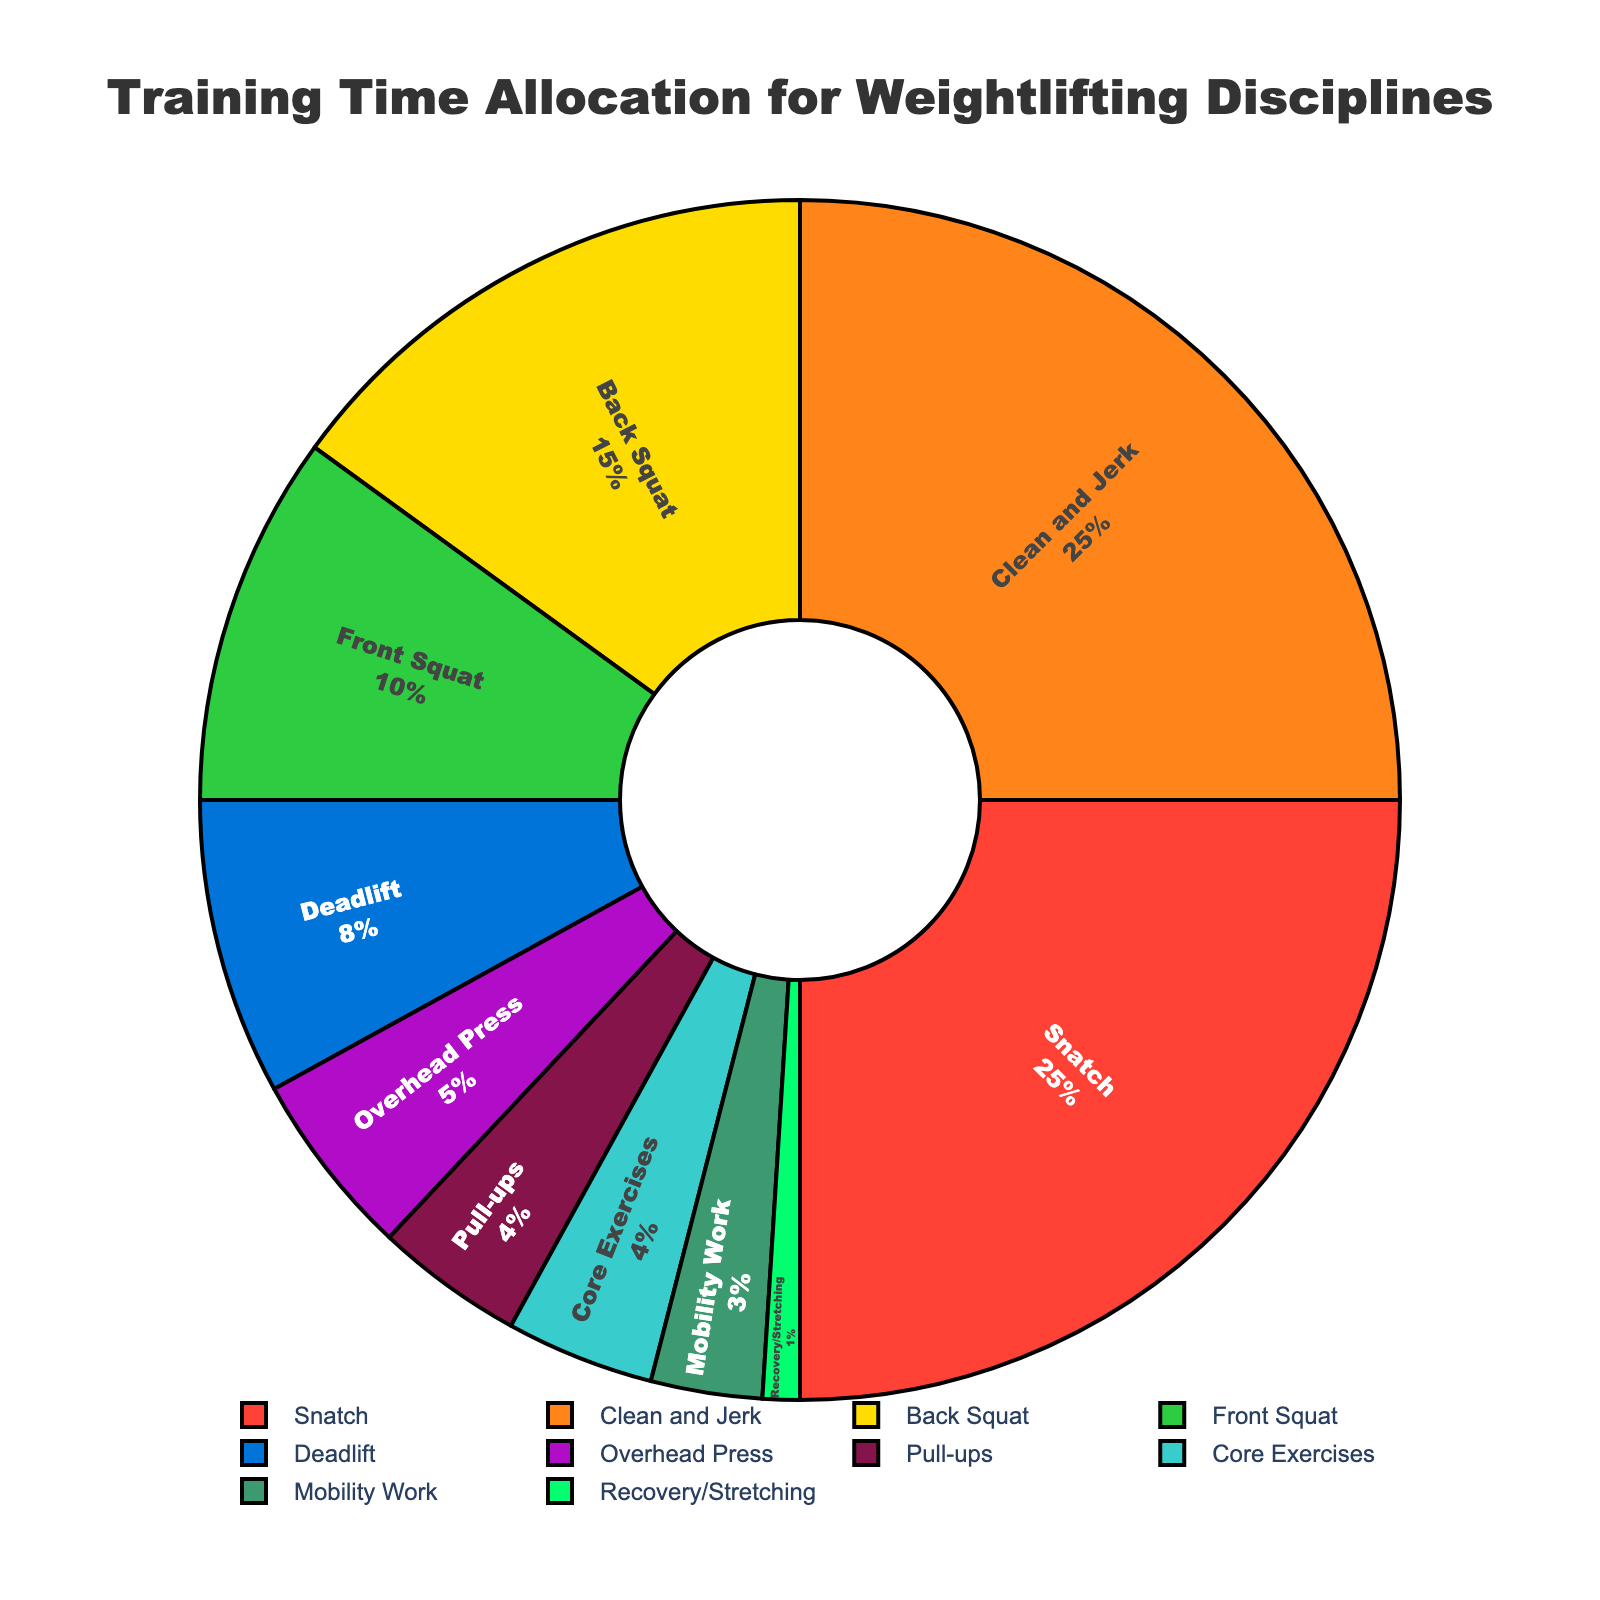Which discipline is allocated the most training time? The pie chart shows the percentages allocated to each discipline. "Snatch" and "Clean and Jerk" have the highest percentages, each with 25%.
Answer: Snatch and Clean and Jerk Which three disciplines together make up half of the training time? Adding up the percentages: Snatch (25%) + Clean and Jerk (25%) + Back Squat (15%) = 65%. This sum exceeds half of the total allocation. Therefore, these three disciplines make up more than half.
Answer: Snatch, Clean and Jerk, Back Squat What is the difference in percentage between "Deadlift" and "Overhead Press"? The pie chart shows Deadlift is 8% and Overhead Press is 5%. The difference is calculated as 8% - 5%.
Answer: 3% Which disciplines have an equal allocation of training time? By checking the percentages shown in the pie chart, "Snatch" and "Clean and Jerk" each have 25%. "Pull-ups" and "Core Exercises" each have 4%.
Answer: Snatch and Clean and Jerk; Pull-ups and Core Exercises How much more training time is allocated to "Back Squat" compared to "Mobility Work"? The pie chart shows Back Squat with 15% and Mobility Work with 3%. The difference can be calculated as 15% - 3%.
Answer: 12% Which discipline is allocated the least training time? According to the pie chart, "Recovery/Stretching" is allocated 1% of the training time, which is the smallest percentage.
Answer: Recovery/Stretching What is the total training time allocated to "Pull-ups" and "Core Exercises" combined? Both disciplines have 4% each of the training time. Summing them gives 4% + 4%.
Answer: 8% Which discipline has the smallest percentage greater than 5%? From the pie chart, the smallest percentage greater than 5% is "Deadlift" with 8%.
Answer: Deadlift Which discipline is visually represented with the color red? The pie chart uses red for the "Snatch" category, as can be visually confirmed.
Answer: Snatch 